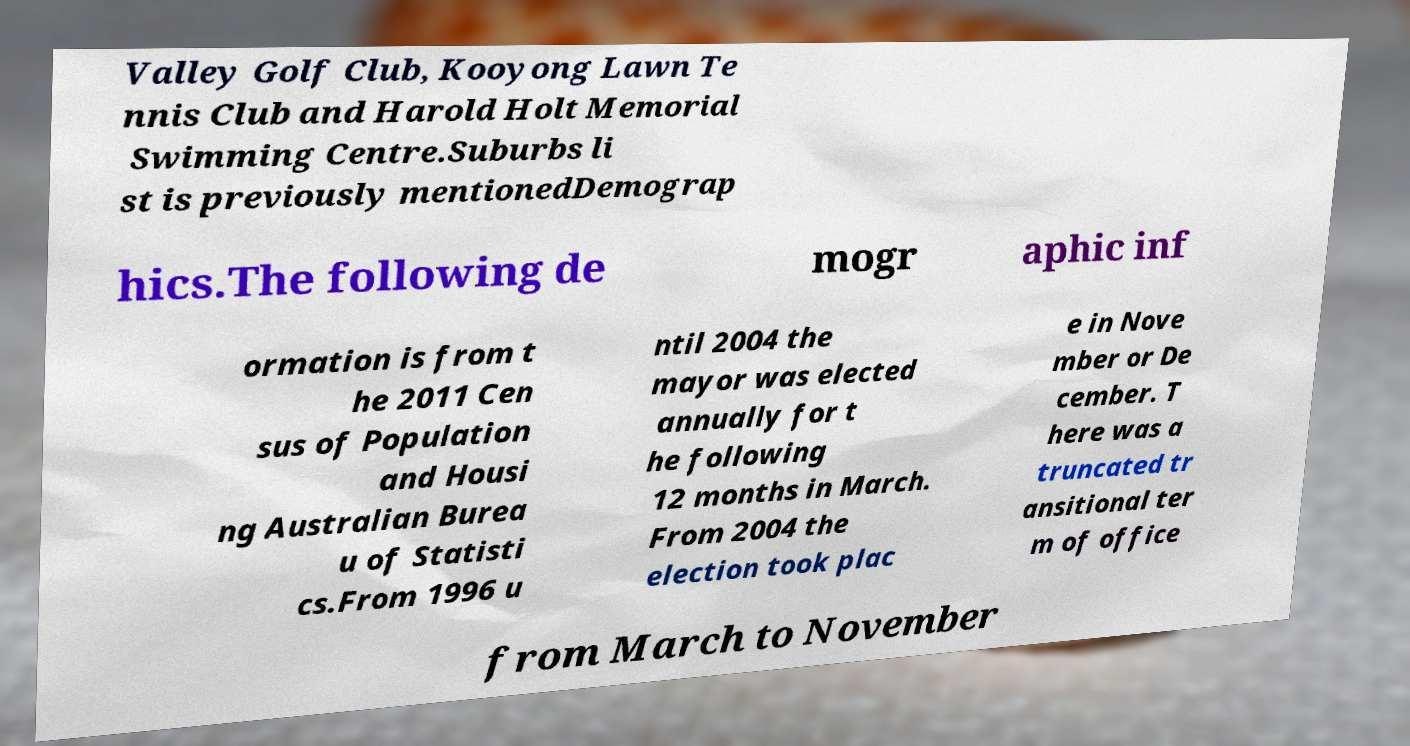For documentation purposes, I need the text within this image transcribed. Could you provide that? Valley Golf Club, Kooyong Lawn Te nnis Club and Harold Holt Memorial Swimming Centre.Suburbs li st is previously mentionedDemograp hics.The following de mogr aphic inf ormation is from t he 2011 Cen sus of Population and Housi ng Australian Burea u of Statisti cs.From 1996 u ntil 2004 the mayor was elected annually for t he following 12 months in March. From 2004 the election took plac e in Nove mber or De cember. T here was a truncated tr ansitional ter m of office from March to November 